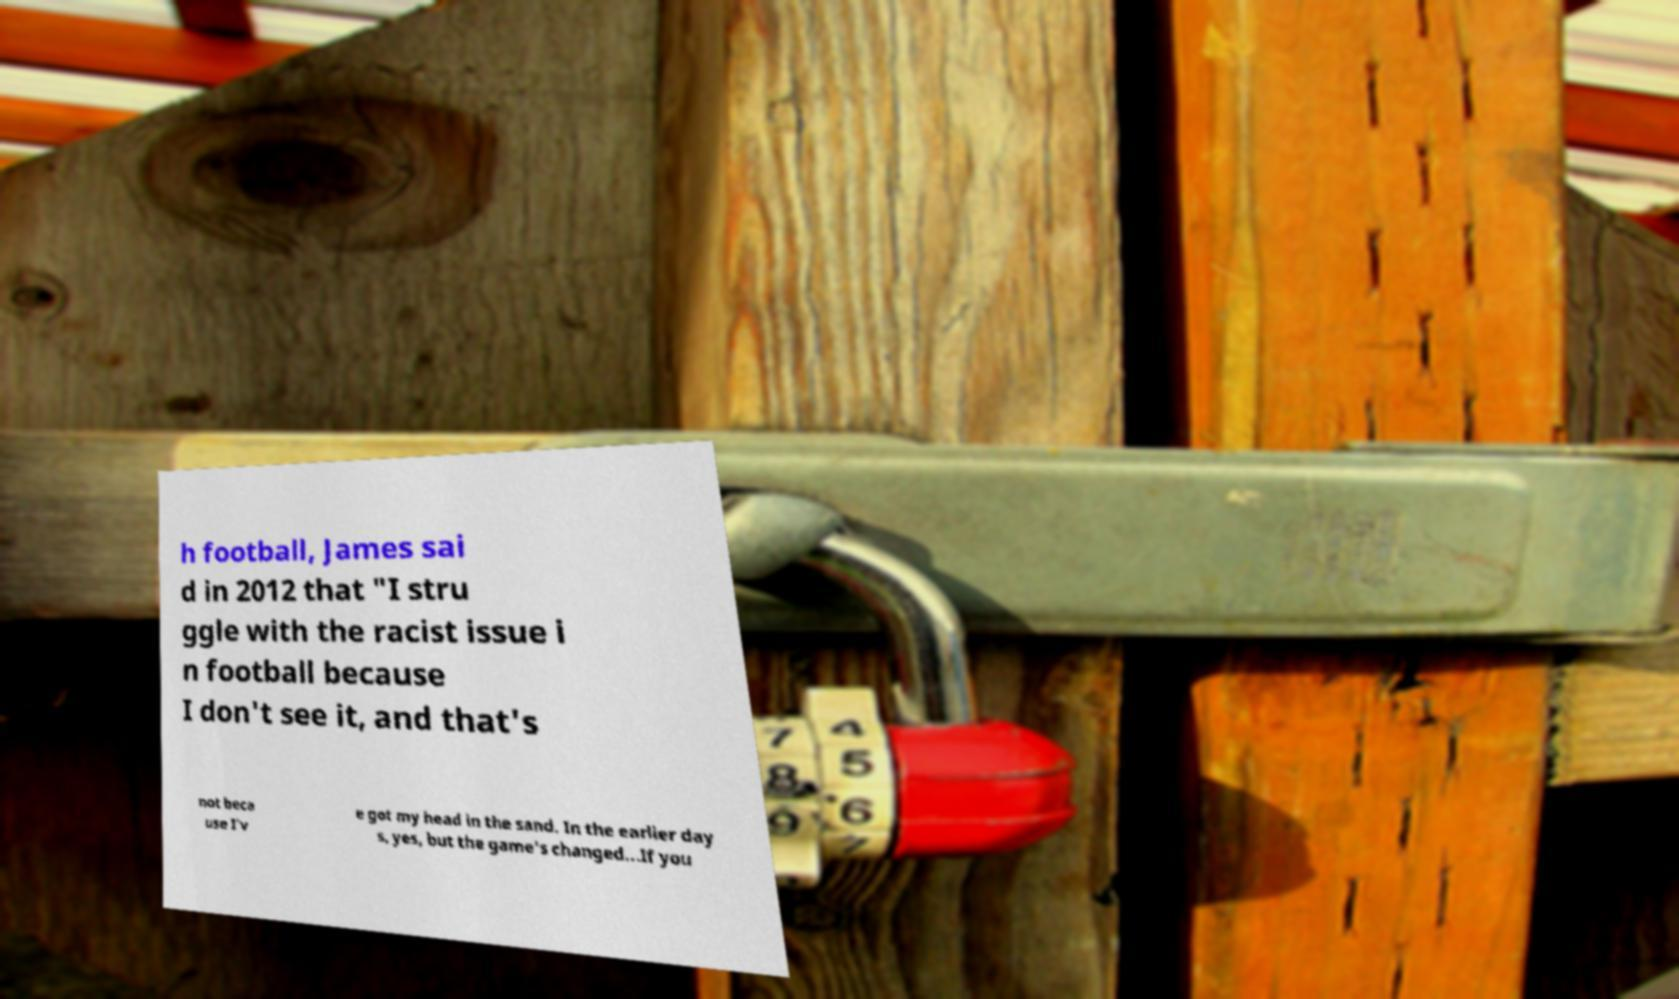Please identify and transcribe the text found in this image. h football, James sai d in 2012 that "I stru ggle with the racist issue i n football because I don't see it, and that's not beca use I'v e got my head in the sand. In the earlier day s, yes, but the game's changed...If you 